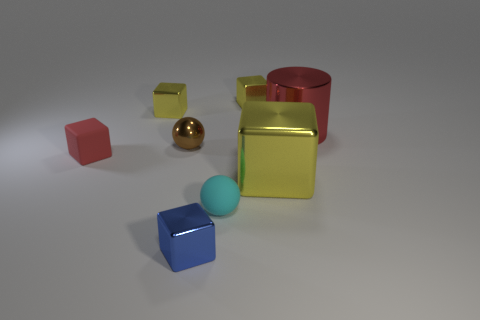What number of other things are the same size as the metallic ball?
Your answer should be compact. 5. How many large objects are metallic cylinders or blue things?
Your answer should be compact. 1. Does the tiny metallic sphere have the same color as the shiny cylinder?
Ensure brevity in your answer.  No. Are there more shiny cubes that are behind the small brown object than small yellow things that are behind the big metal block?
Give a very brief answer. No. There is a big thing in front of the tiny red object; is it the same color as the cylinder?
Your answer should be very brief. No. Are there any other things that have the same color as the large metallic cylinder?
Your answer should be very brief. Yes. Is the number of red rubber cubes on the right side of the red metallic thing greater than the number of tiny metal cylinders?
Give a very brief answer. No. Do the cylinder and the metal ball have the same size?
Give a very brief answer. No. What material is the other large thing that is the same shape as the red rubber thing?
Your answer should be compact. Metal. How many green objects are either cubes or metal spheres?
Make the answer very short. 0. 